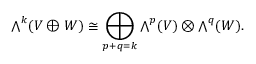Convert formula to latex. <formula><loc_0><loc_0><loc_500><loc_500>{ \bigwedge } ^ { k } ( V \oplus W ) \cong \bigoplus _ { p + q = k } { \bigwedge } ^ { p } ( V ) \otimes { \bigwedge } ^ { q } ( W ) .</formula> 